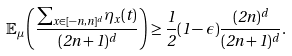<formula> <loc_0><loc_0><loc_500><loc_500>\mathbb { E } _ { \mu } \left ( \frac { \sum _ { x \in [ - n , n ] ^ { d } } \eta _ { x } ( t ) } { ( 2 n + 1 ) ^ { d } } \right ) \geq \frac { 1 } { 2 } ( 1 - \epsilon ) \frac { ( 2 n ) ^ { d } } { ( 2 n + 1 ) ^ { d } } .</formula> 